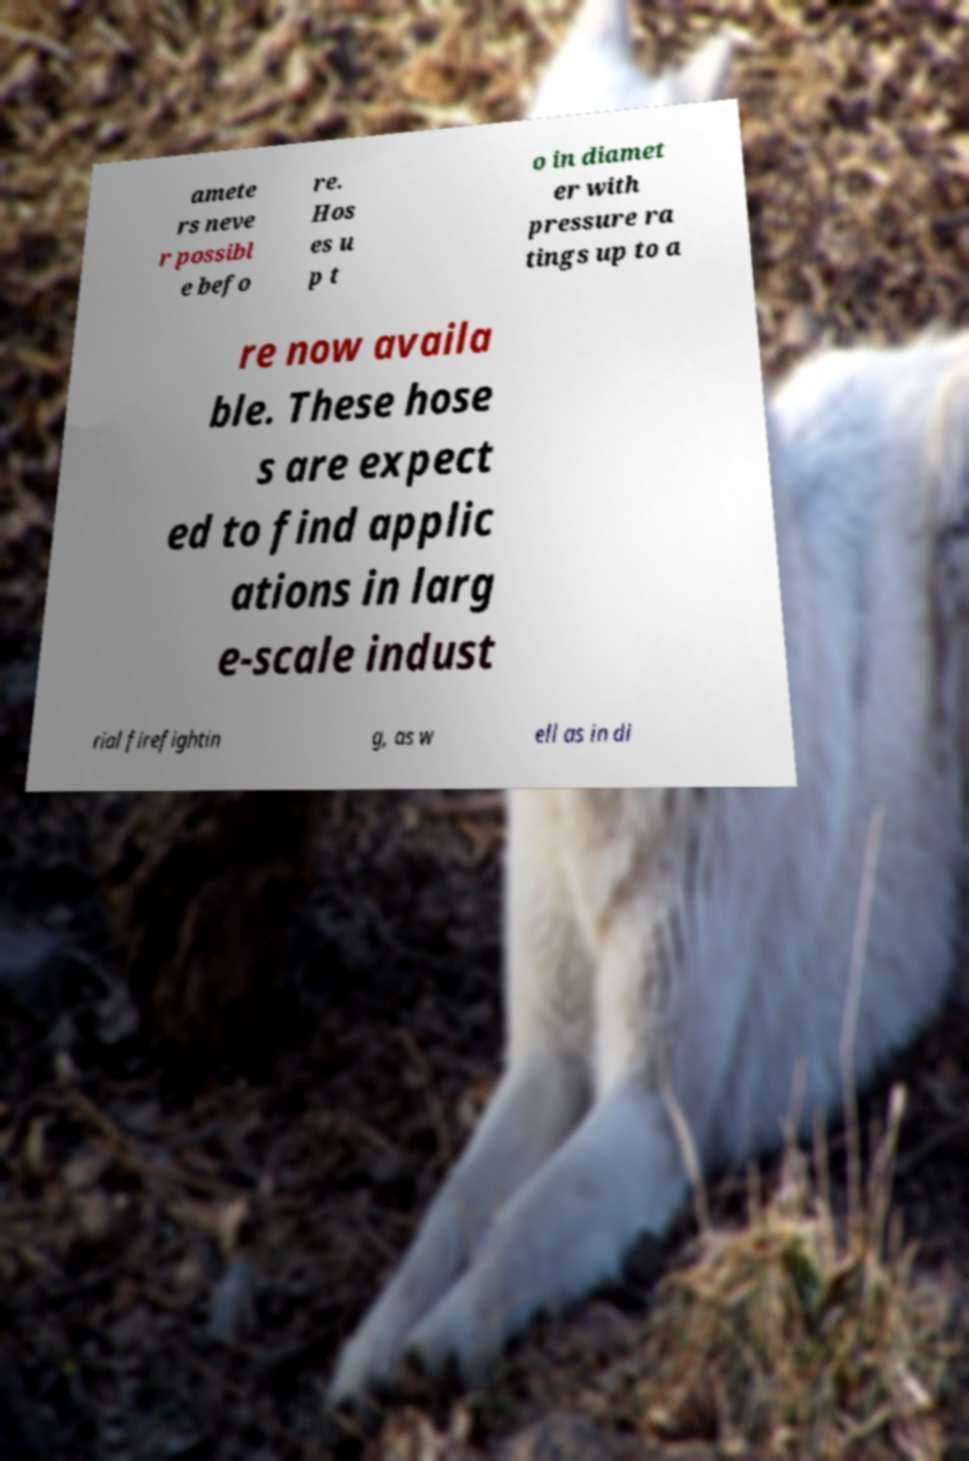Can you accurately transcribe the text from the provided image for me? amete rs neve r possibl e befo re. Hos es u p t o in diamet er with pressure ra tings up to a re now availa ble. These hose s are expect ed to find applic ations in larg e-scale indust rial firefightin g, as w ell as in di 